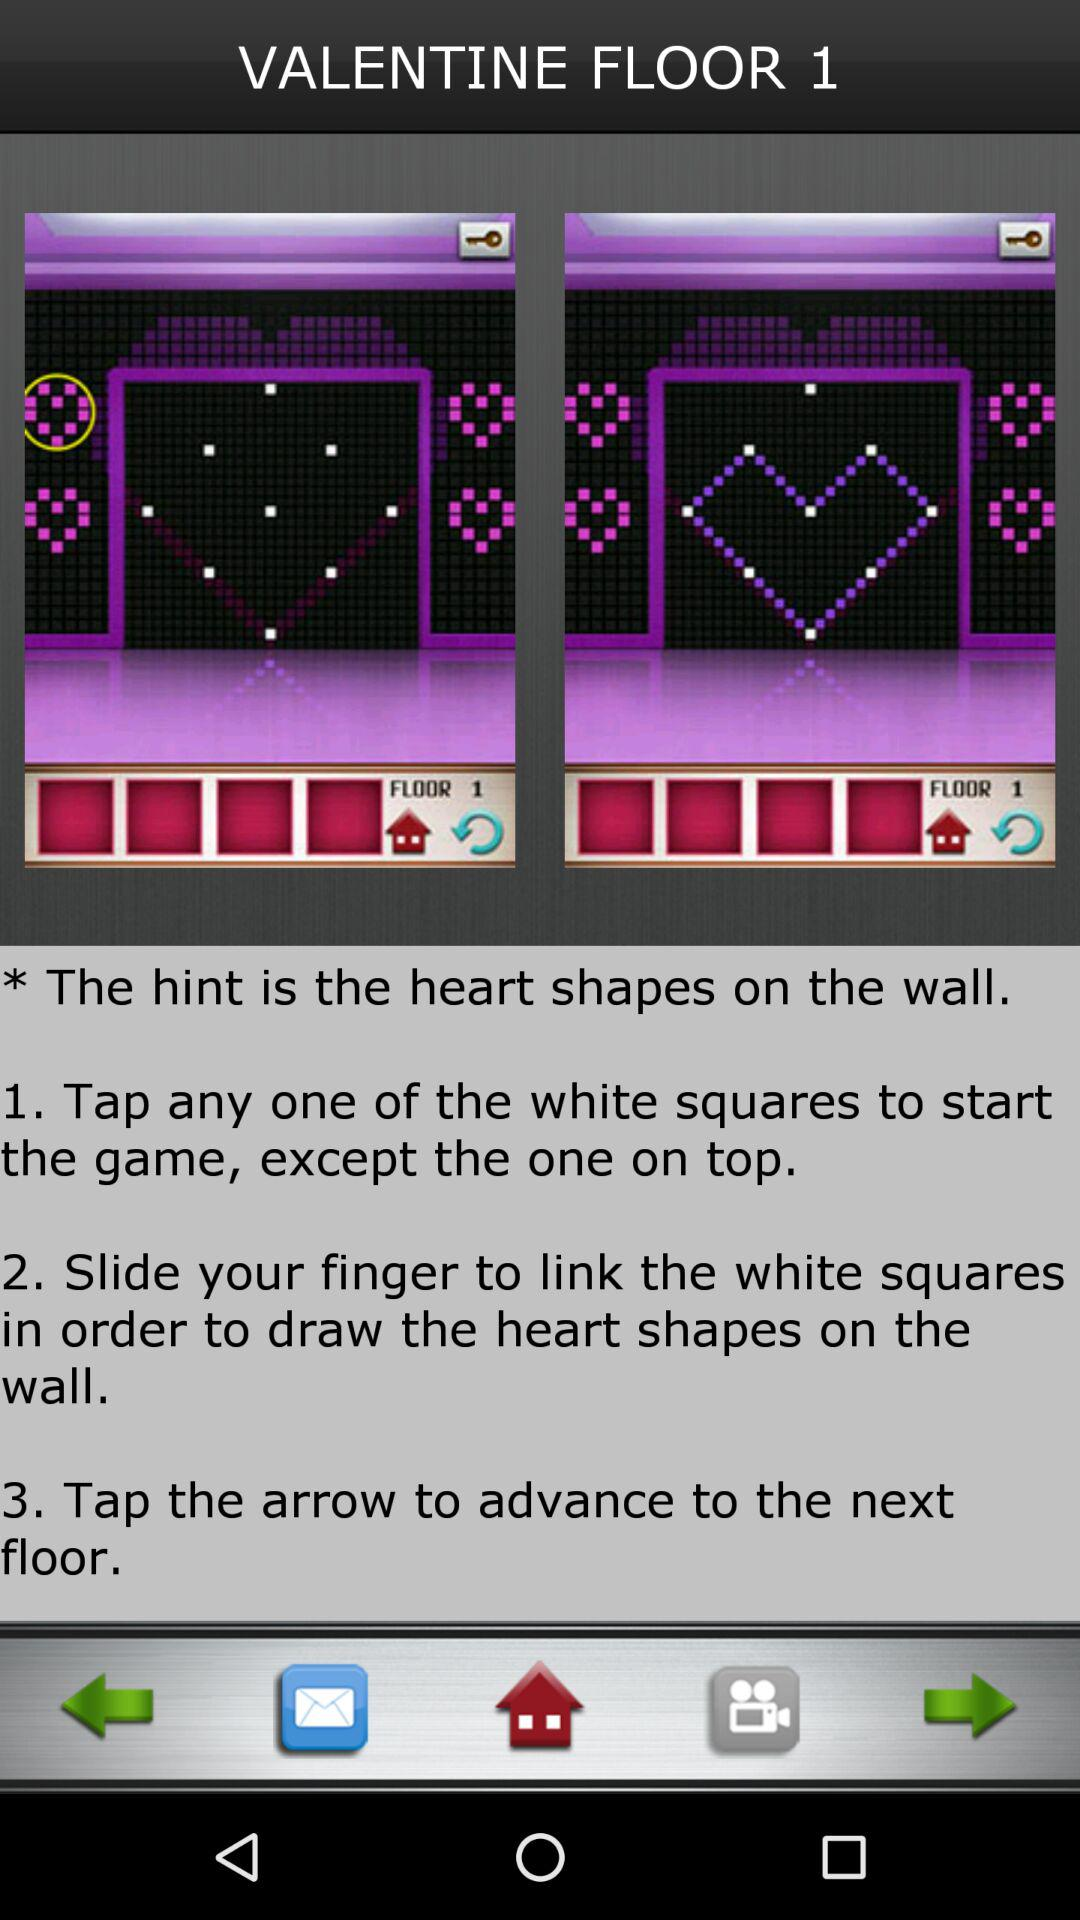What is the name of the shown game? The name of the game is "VALENTINE FLOOR". 